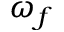<formula> <loc_0><loc_0><loc_500><loc_500>\omega _ { f }</formula> 